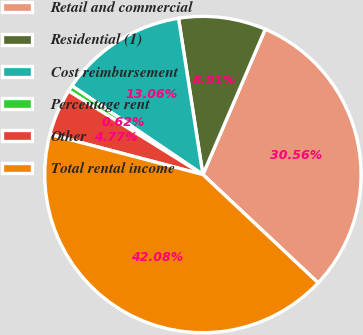<chart> <loc_0><loc_0><loc_500><loc_500><pie_chart><fcel>Retail and commercial<fcel>Residential (1)<fcel>Cost reimbursement<fcel>Percentage rent<fcel>Other<fcel>Total rental income<nl><fcel>30.56%<fcel>8.91%<fcel>13.06%<fcel>0.62%<fcel>4.77%<fcel>42.08%<nl></chart> 